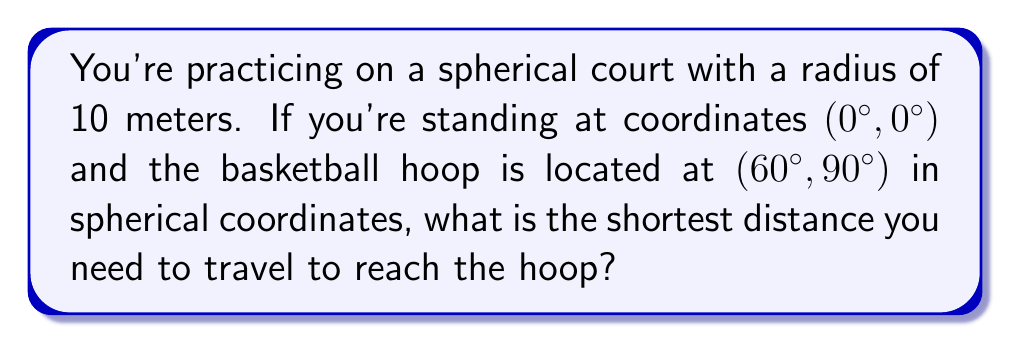Can you solve this math problem? To solve this problem, we need to use the great circle distance formula, which gives the shortest path between two points on a sphere. Here's how we can approach this step-by-step:

1. We're given the following information:
   - Radius of the spherical court: $R = 10$ meters
   - Your position: $(\phi_1, \lambda_1) = (0°, 0°)$
   - Hoop position: $(\phi_2, \lambda_2) = (60°, 90°)$

2. The great circle distance formula is:

   $$d = R \cdot \arccos(\sin\phi_1 \sin\phi_2 + \cos\phi_1 \cos\phi_2 \cos(\Delta\lambda))$$

   Where:
   - $d$ is the distance
   - $R$ is the radius of the sphere
   - $\phi_1$ and $\phi_2$ are the latitudes of the two points
   - $\Delta\lambda$ is the absolute difference in longitude

3. Let's convert our angles to radians:
   - $\phi_1 = 0° = 0$ radians
   - $\phi_2 = 60° = \frac{\pi}{3}$ radians
   - $\Delta\lambda = 90° = \frac{\pi}{2}$ radians

4. Now, let's substitute these values into the formula:

   $$d = 10 \cdot \arccos(\sin(0) \sin(\frac{\pi}{3}) + \cos(0) \cos(\frac{\pi}{3}) \cos(\frac{\pi}{2}))$$

5. Simplify:
   - $\sin(0) = 0$
   - $\cos(0) = 1$
   - $\sin(\frac{\pi}{3}) = \frac{\sqrt{3}}{2}$
   - $\cos(\frac{\pi}{3}) = \frac{1}{2}$
   - $\cos(\frac{\pi}{2}) = 0$

   $$d = 10 \cdot \arccos(0 \cdot \frac{\sqrt{3}}{2} + 1 \cdot \frac{1}{2} \cdot 0)$$
   $$d = 10 \cdot \arccos(0)$$

6. We know that $\arccos(0) = \frac{\pi}{2}$, so:

   $$d = 10 \cdot \frac{\pi}{2} = 5\pi \approx 15.71$$

Therefore, the shortest distance you need to travel is approximately 15.71 meters.
Answer: $5\pi$ meters 